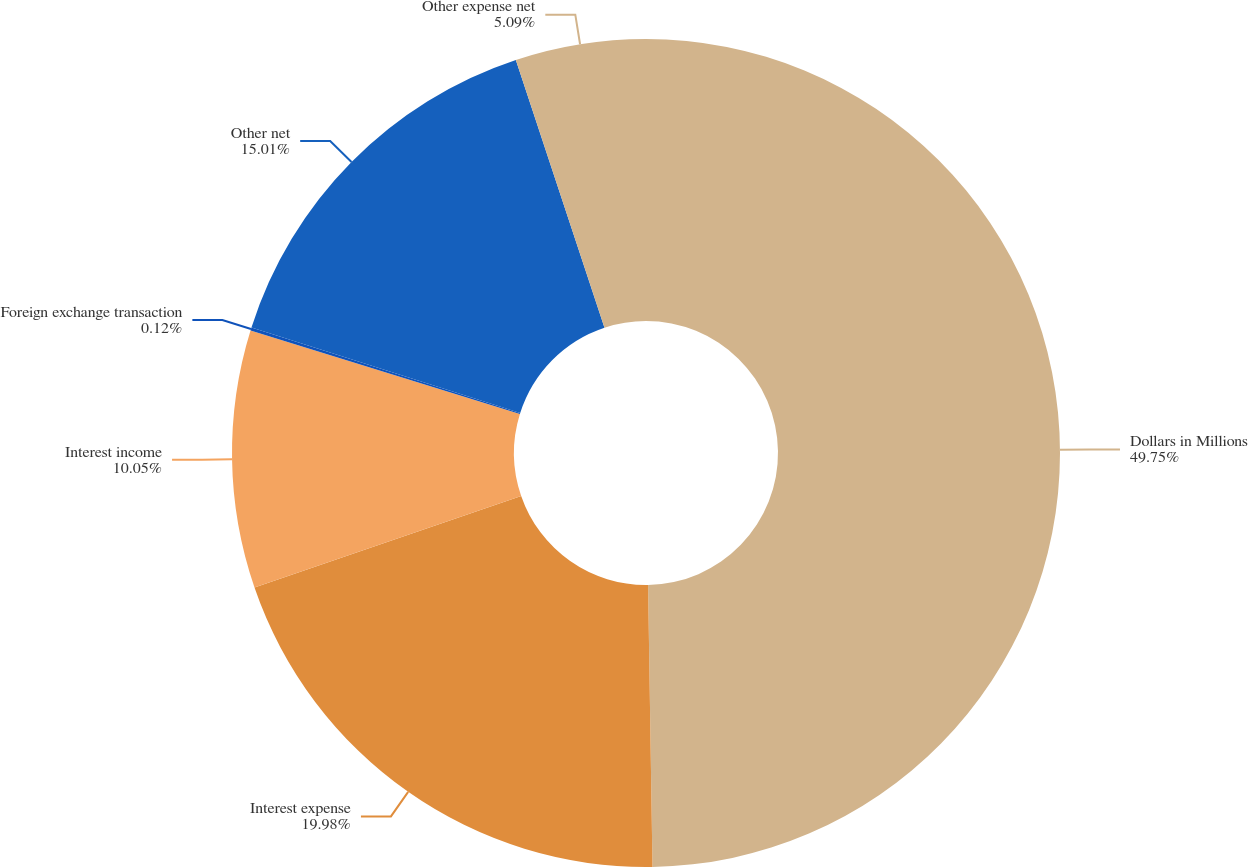Convert chart. <chart><loc_0><loc_0><loc_500><loc_500><pie_chart><fcel>Dollars in Millions<fcel>Interest expense<fcel>Interest income<fcel>Foreign exchange transaction<fcel>Other net<fcel>Other expense net<nl><fcel>49.75%<fcel>19.98%<fcel>10.05%<fcel>0.12%<fcel>15.01%<fcel>5.09%<nl></chart> 